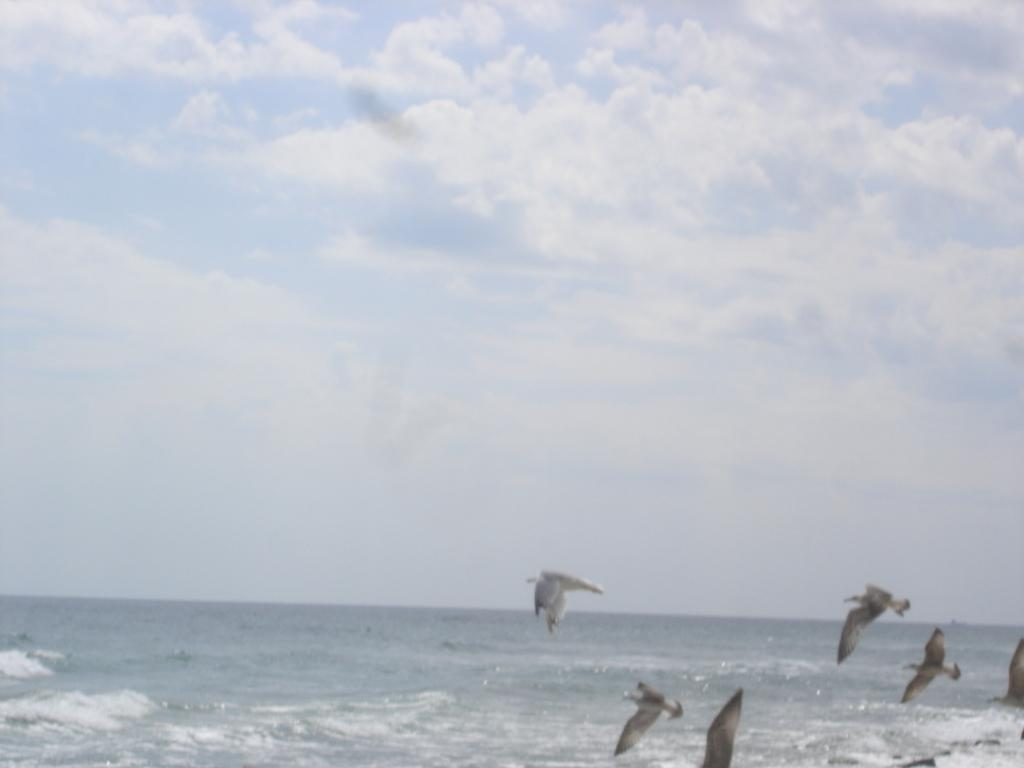What is the main element present in the image? There is water in the image. What is happening in the sky in the image? Birds are flying in the air in the image. What can be seen in the background of the image? The sky is visible in the background of the image. What is the condition of the sky in the image? Clouds are present in the sky. Can you see a plane flying alongside the birds in the image? There is no plane visible in the image; only birds are flying in the air. Is there a bear swimming in the water in the image? There is no bear present in the image; it features water and birds flying in the air. 